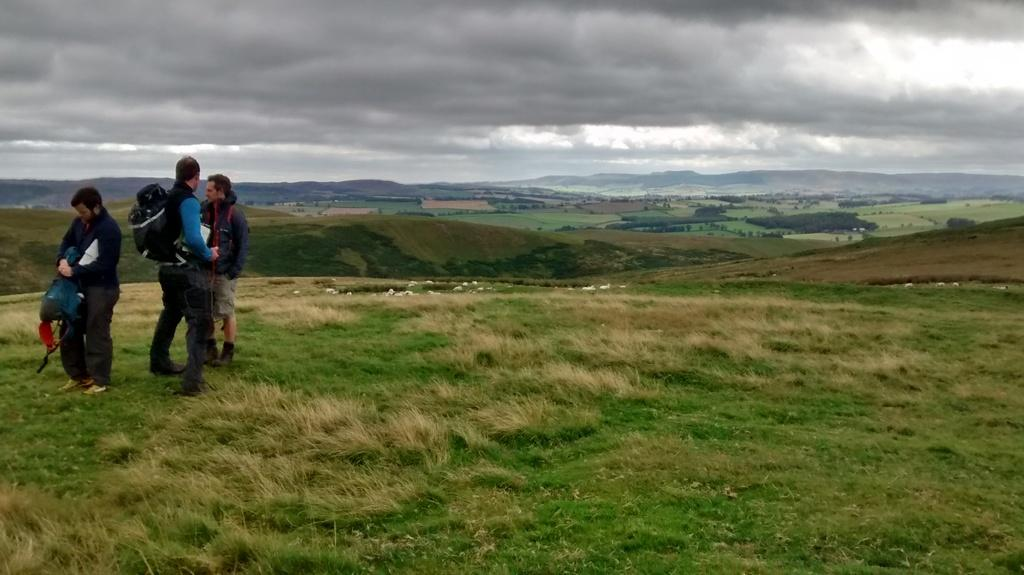How many people are in the image? There are three persons in the image. What are the persons wearing on their backs? The persons are wearing backpacks. What type of vegetation is present in the image? There is grass and trees in the image. What type of landscape feature can be seen in the background? There are mountains in the image. What is visible in the sky in the image? The sky is visible in the image. What type of attraction can be seen in the image? There is no attraction present in the image; it features three persons wearing backpacks in a natural environment with mountains, trees, and grass. How does the feeling of the persons in the image change throughout the day? The image does not provide information about the feelings of the persons, nor does it depict a specific time of day. 